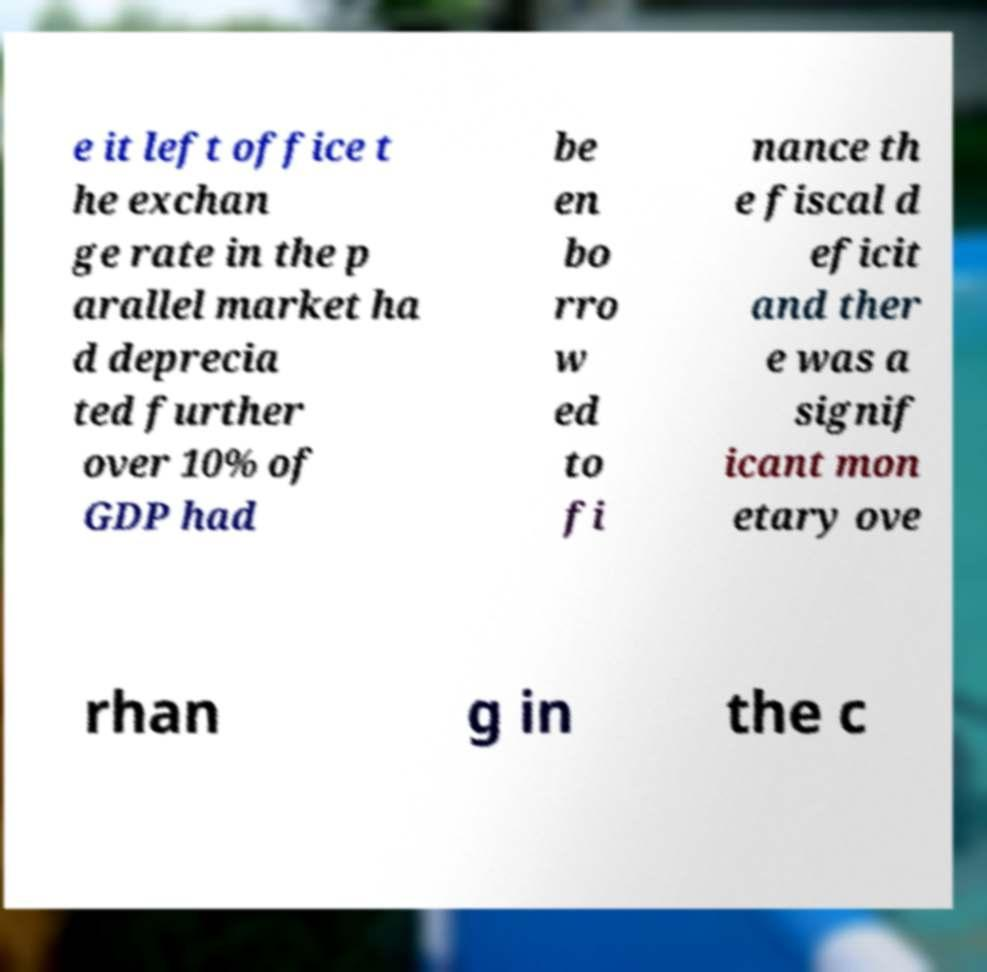Can you read and provide the text displayed in the image?This photo seems to have some interesting text. Can you extract and type it out for me? e it left office t he exchan ge rate in the p arallel market ha d deprecia ted further over 10% of GDP had be en bo rro w ed to fi nance th e fiscal d eficit and ther e was a signif icant mon etary ove rhan g in the c 